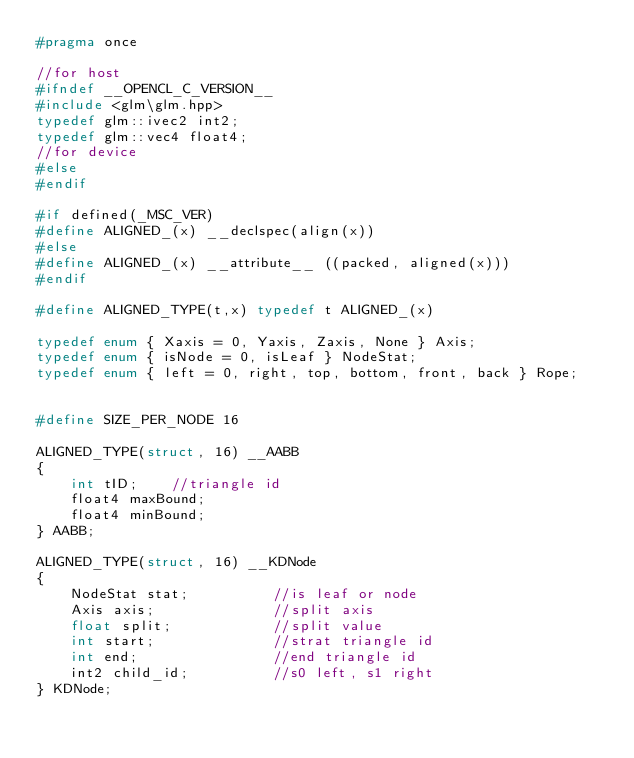Convert code to text. <code><loc_0><loc_0><loc_500><loc_500><_C_>#pragma once

//for host
#ifndef __OPENCL_C_VERSION__
#include <glm\glm.hpp>
typedef glm::ivec2 int2;
typedef glm::vec4 float4;
//for device
#else
#endif

#if defined(_MSC_VER)
#define ALIGNED_(x) __declspec(align(x))
#else
#define ALIGNED_(x) __attribute__ ((packed, aligned(x)))
#endif

#define ALIGNED_TYPE(t,x) typedef t ALIGNED_(x)

typedef enum { Xaxis = 0, Yaxis, Zaxis, None } Axis;
typedef enum { isNode = 0, isLeaf } NodeStat;
typedef enum { left = 0, right, top, bottom, front, back } Rope;


#define SIZE_PER_NODE 16

ALIGNED_TYPE(struct, 16) __AABB
{
	int tID;    //triangle id
	float4 maxBound;
	float4 minBound;
} AABB;

ALIGNED_TYPE(struct, 16) __KDNode
{
	NodeStat stat;			//is leaf or node
	Axis axis;              //split axis
	float split;            //split value
	int start;				//strat triangle id 
	int end;				//end triangle id
	int2 child_id;			//s0 left, s1 right
} KDNode;
</code> 